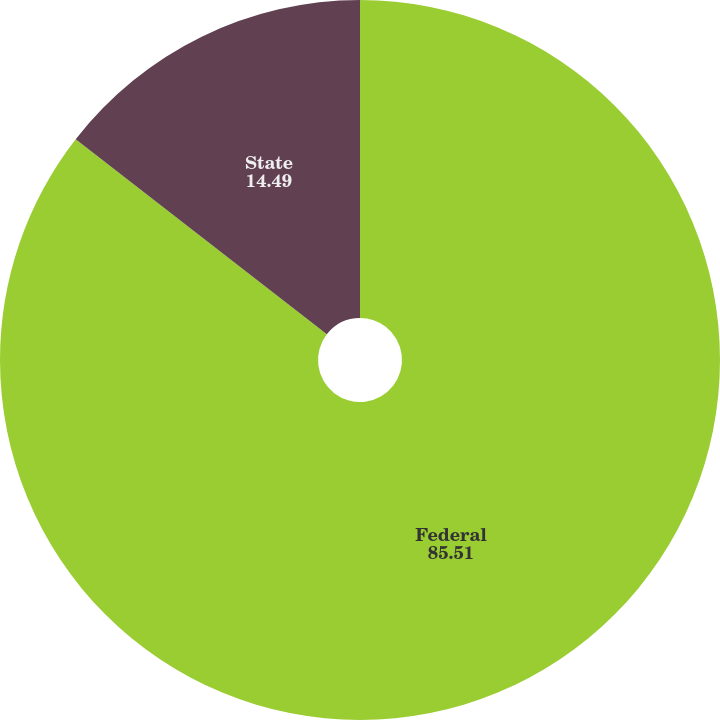Convert chart. <chart><loc_0><loc_0><loc_500><loc_500><pie_chart><fcel>Federal<fcel>State<nl><fcel>85.51%<fcel>14.49%<nl></chart> 